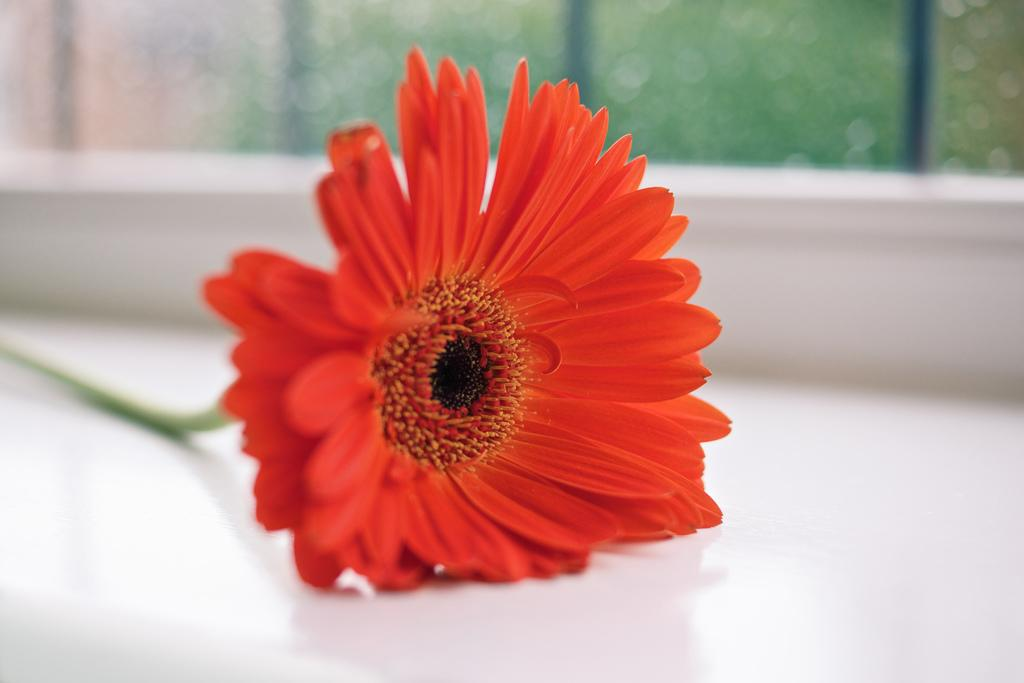What type of flower is in the picture? There is a red flower in the picture. What color is the surface on which the red flower is placed? The red flower is on a white surface. Can you describe the background of the image? The background of the image is blurry. How many apples are hidden in the pocket of the person in the image? There is no person or pocket visible in the image, and therefore no apples can be found. 